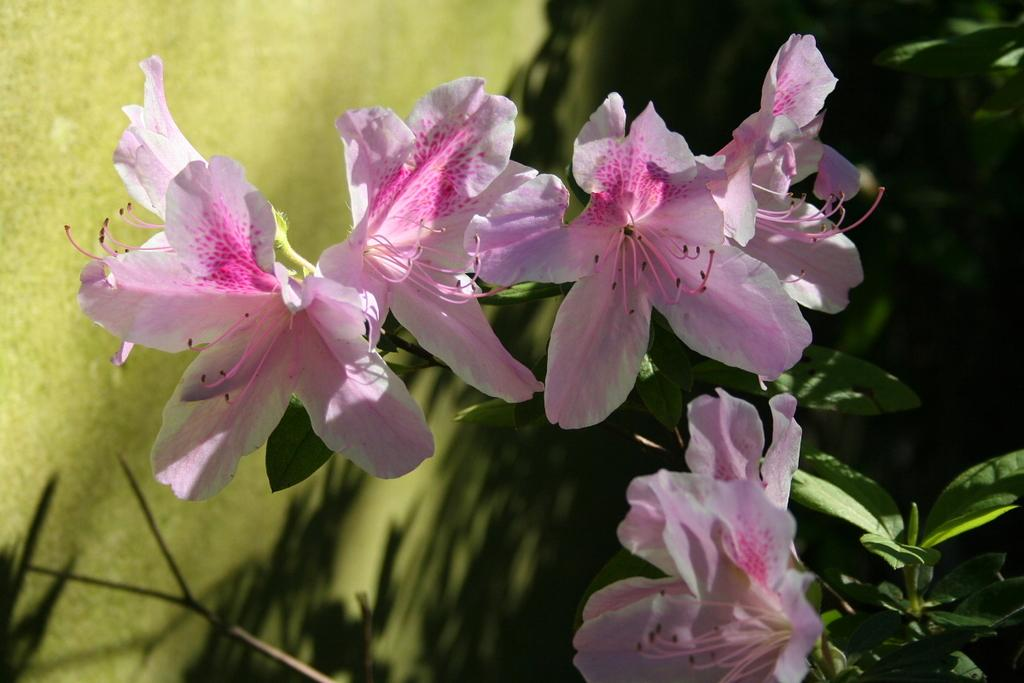What type of flowers can be seen in the image? There are pink flowers in the image. Where are the flowers located? The flowers are on a plant. What can be observed about the background of the flowers? The background of the flowers is blurred. What channel is the trade of these flowers conducted on in the image? There is no reference to a channel or trade in the image, as it simply features pink flowers on a plant with a blurred background. 